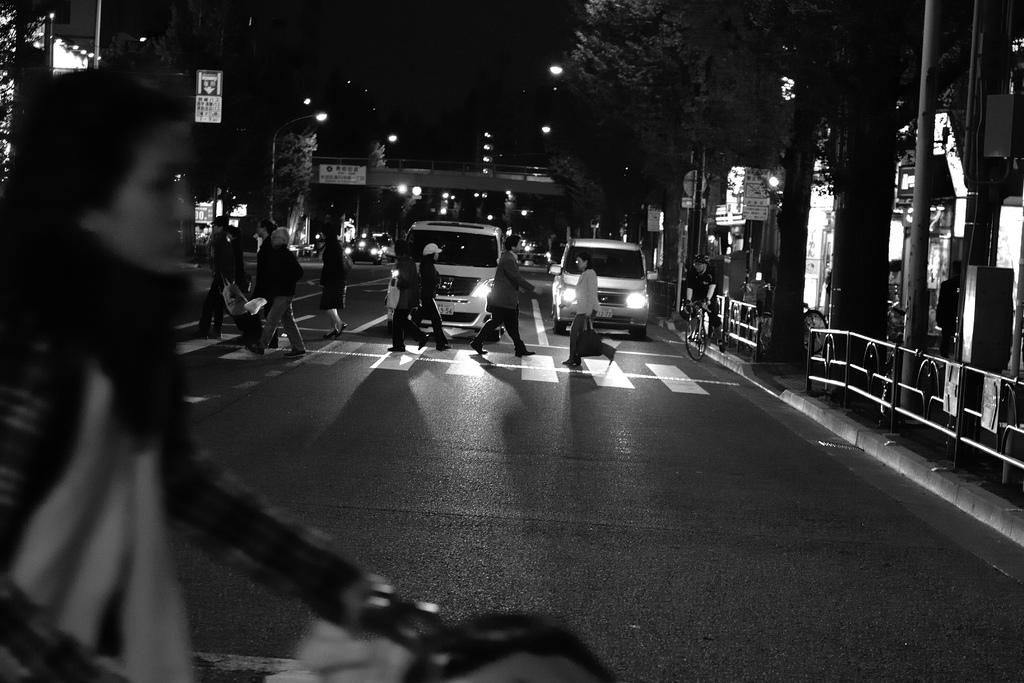What is happening in the image involving a group of people? The people in the image are crossing the road. What can be seen in the background of the image? There are vehicles visible in the background of the image. What is the price of the voice heard in the image? There is no voice present in the image, so it is not possible to determine a price for it. 